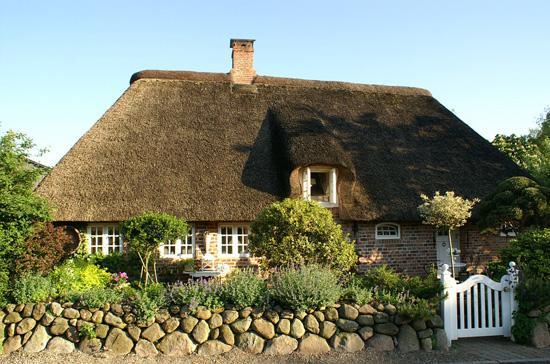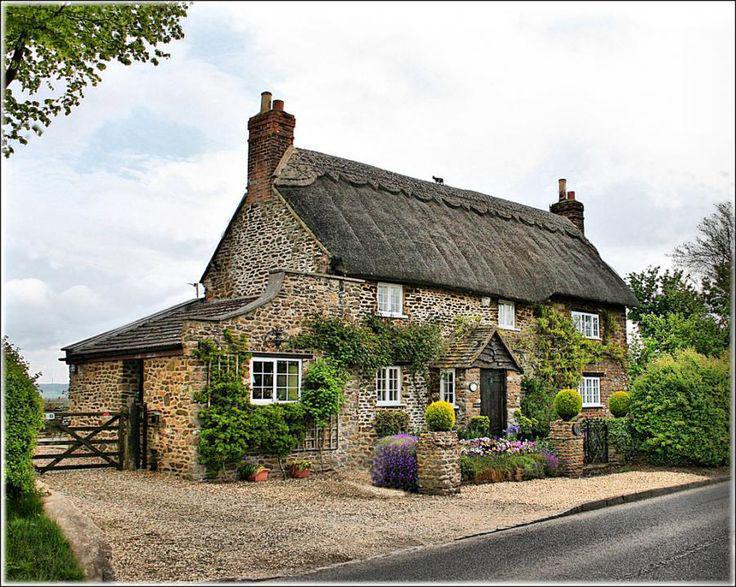The first image is the image on the left, the second image is the image on the right. Considering the images on both sides, is "In the left image, a picket fence is in front of a house with paned windows and a thick grayish roof with at least one notch to accommodate an upper story window." valid? Answer yes or no. No. The first image is the image on the left, the second image is the image on the right. For the images shown, is this caption "There is a thatched roof cottage that has a picket fence." true? Answer yes or no. No. 